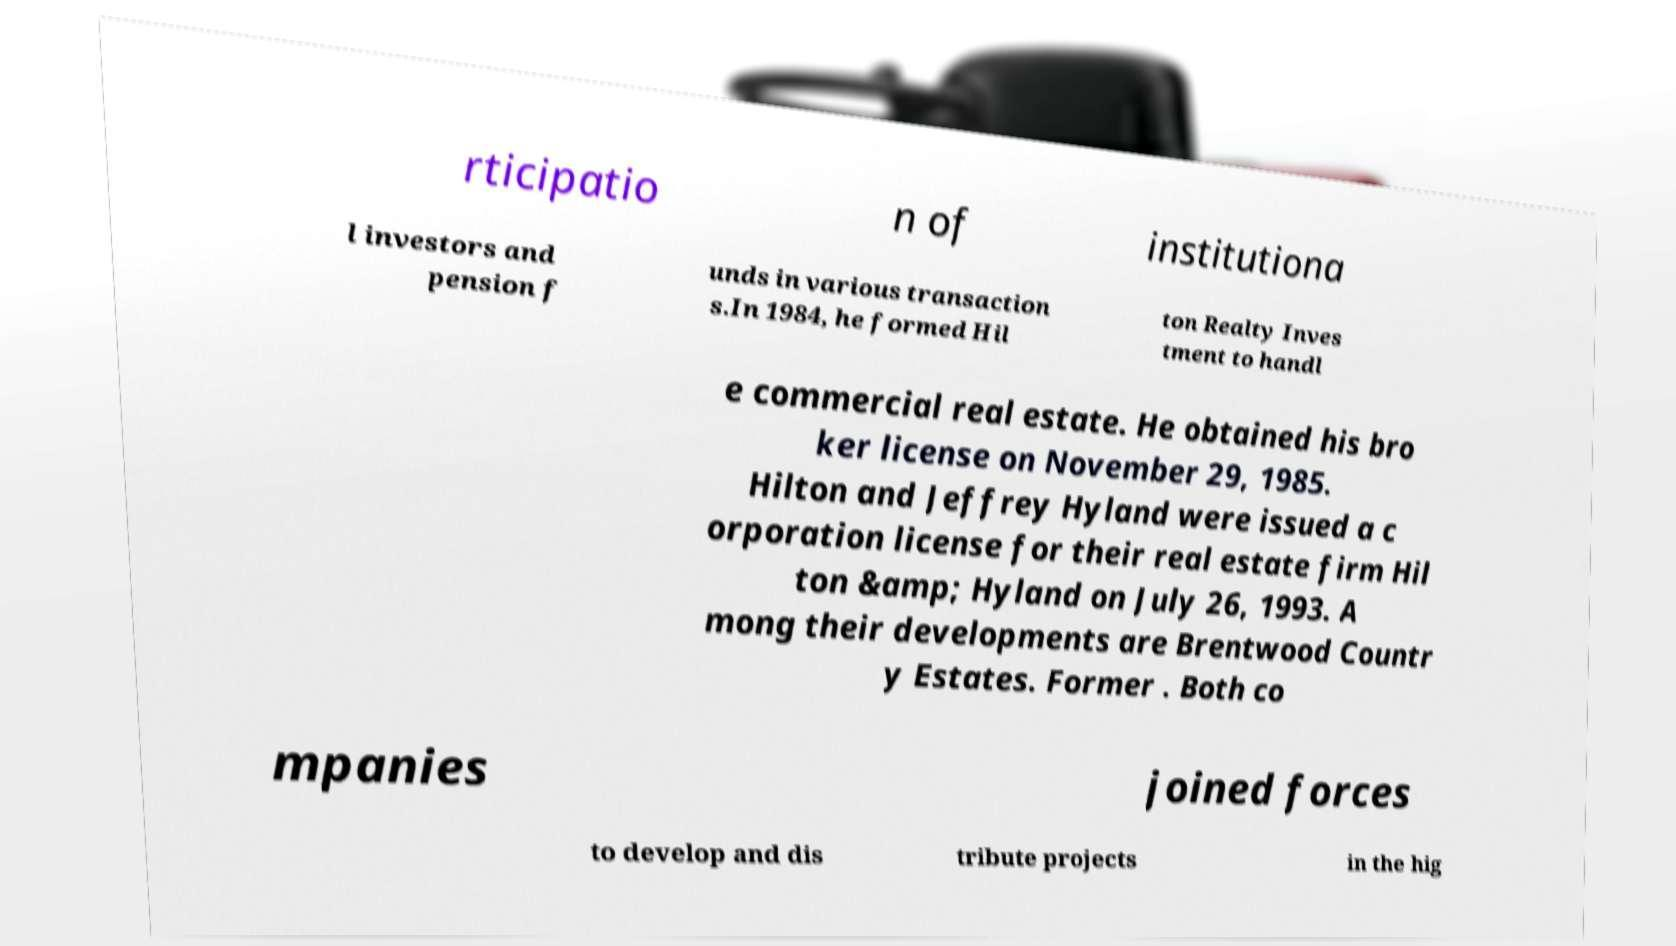There's text embedded in this image that I need extracted. Can you transcribe it verbatim? rticipatio n of institutiona l investors and pension f unds in various transaction s.In 1984, he formed Hil ton Realty Inves tment to handl e commercial real estate. He obtained his bro ker license on November 29, 1985. Hilton and Jeffrey Hyland were issued a c orporation license for their real estate firm Hil ton &amp; Hyland on July 26, 1993. A mong their developments are Brentwood Countr y Estates. Former . Both co mpanies joined forces to develop and dis tribute projects in the hig 